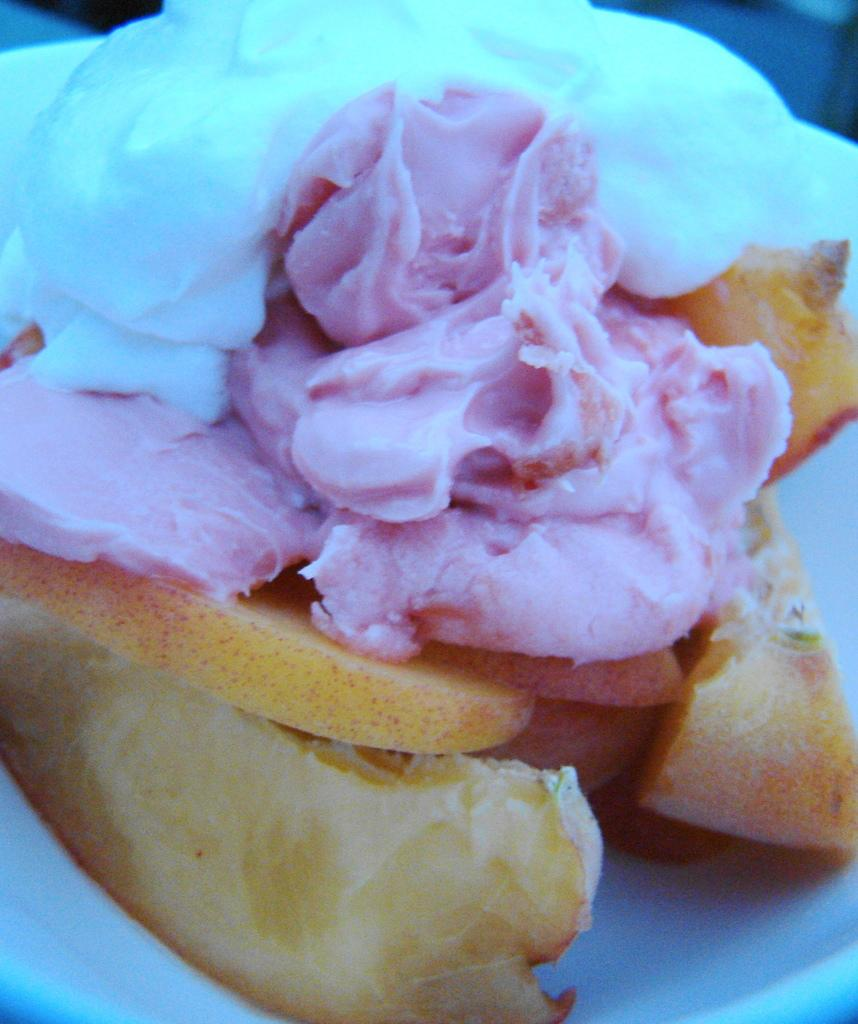What is on the plate in the image? There is food on a white color plate in the image. What type of food can be seen on the plate? The food is in pink, white, and yellow colors. Are there any fruits visible in the image? Yes, there are fruits in the image. What type of government is depicted in the image? There is no depiction of a government in the image; it features food on a plate and fruits. How many chickens are present in the image? There are no chickens present in the image. 